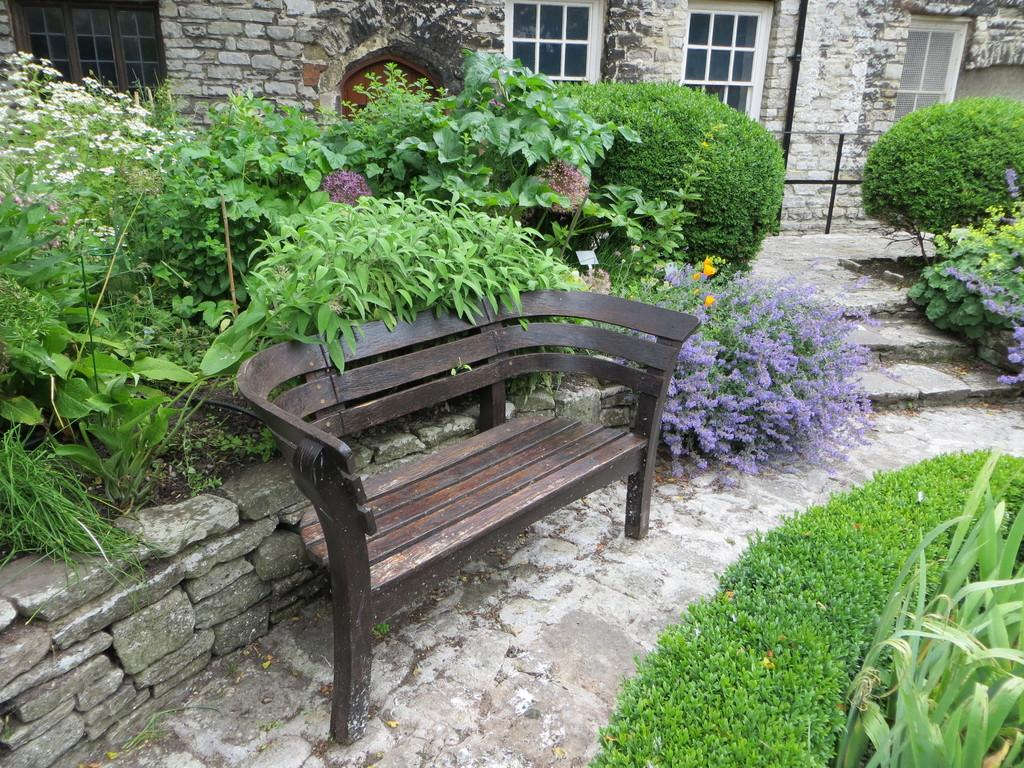What type of seating is visible in the image? There is a bench in the image. What can be found on the ground in the image? There are plants on the ground in the image. What is visible in the background of the image? There is a building in the background of the image. What architectural feature is present in the image? There are stairs in the image. What type of hook is visible in the image? There is no hook present in the image. What emotion does the image evoke in the viewer? The image does not evoke any specific emotion, such as disgust, as it is a neutral scene with a bench, plants, a building, and stairs. 